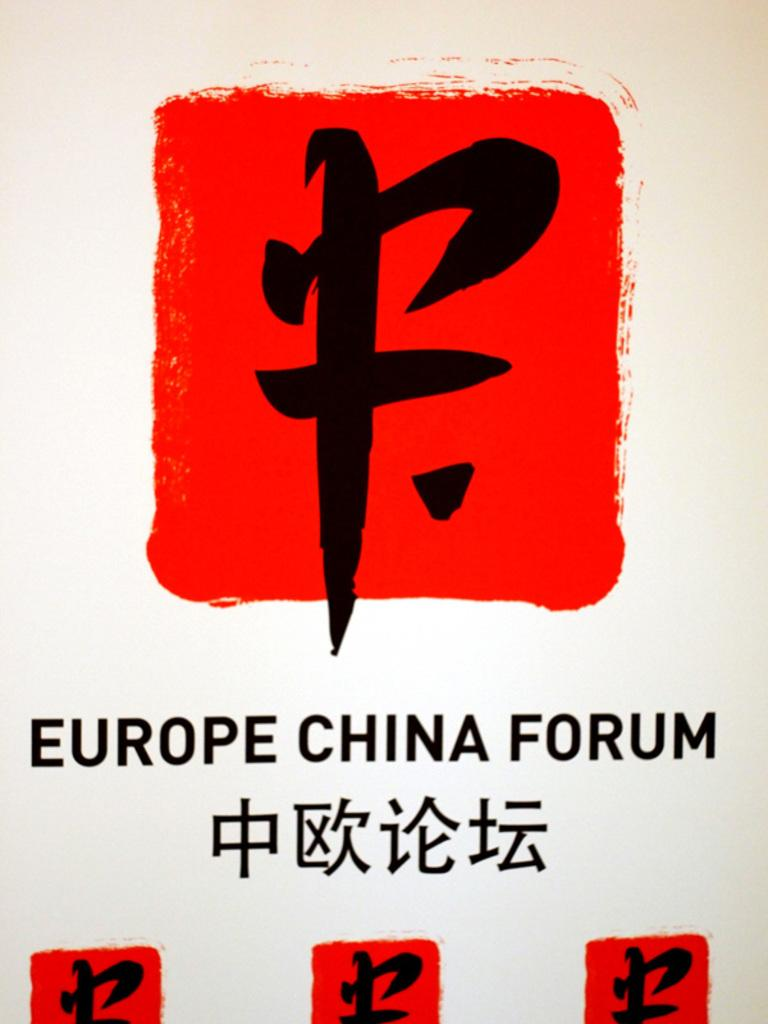Provide a one-sentence caption for the provided image. A red and white sign with Chinese symbols that say Europe China Forum. 